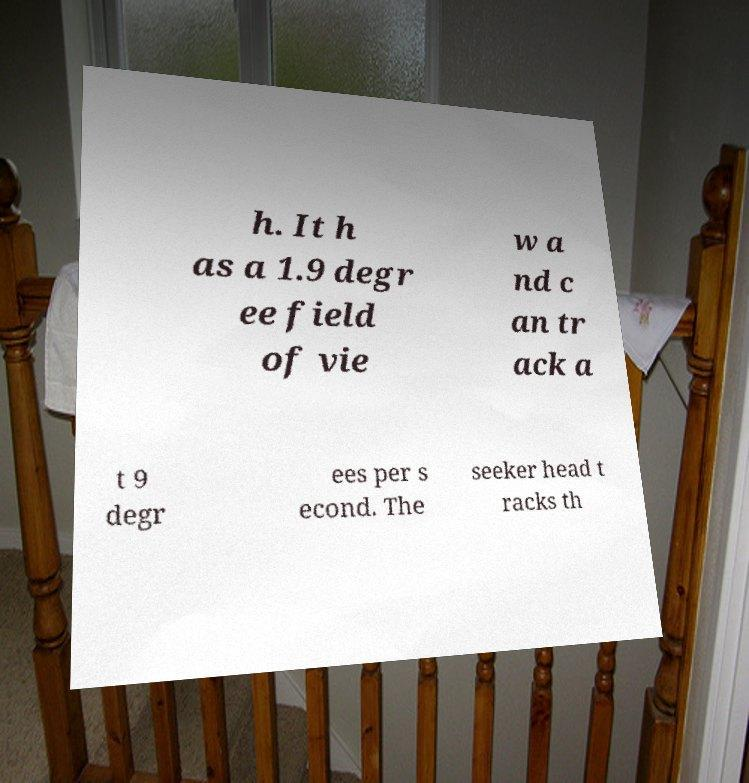What messages or text are displayed in this image? I need them in a readable, typed format. h. It h as a 1.9 degr ee field of vie w a nd c an tr ack a t 9 degr ees per s econd. The seeker head t racks th 